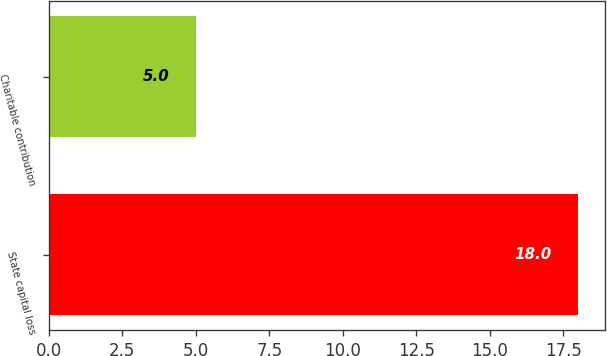<chart> <loc_0><loc_0><loc_500><loc_500><bar_chart><fcel>State capital loss<fcel>Charitable contribution<nl><fcel>18<fcel>5<nl></chart> 